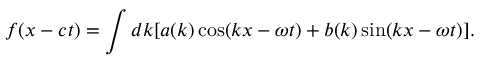<formula> <loc_0><loc_0><loc_500><loc_500>f ( x - c t ) = \int d k [ a ( k ) \cos ( k x - \omega t ) + b ( k ) \sin ( k x - \omega t ) ] .</formula> 